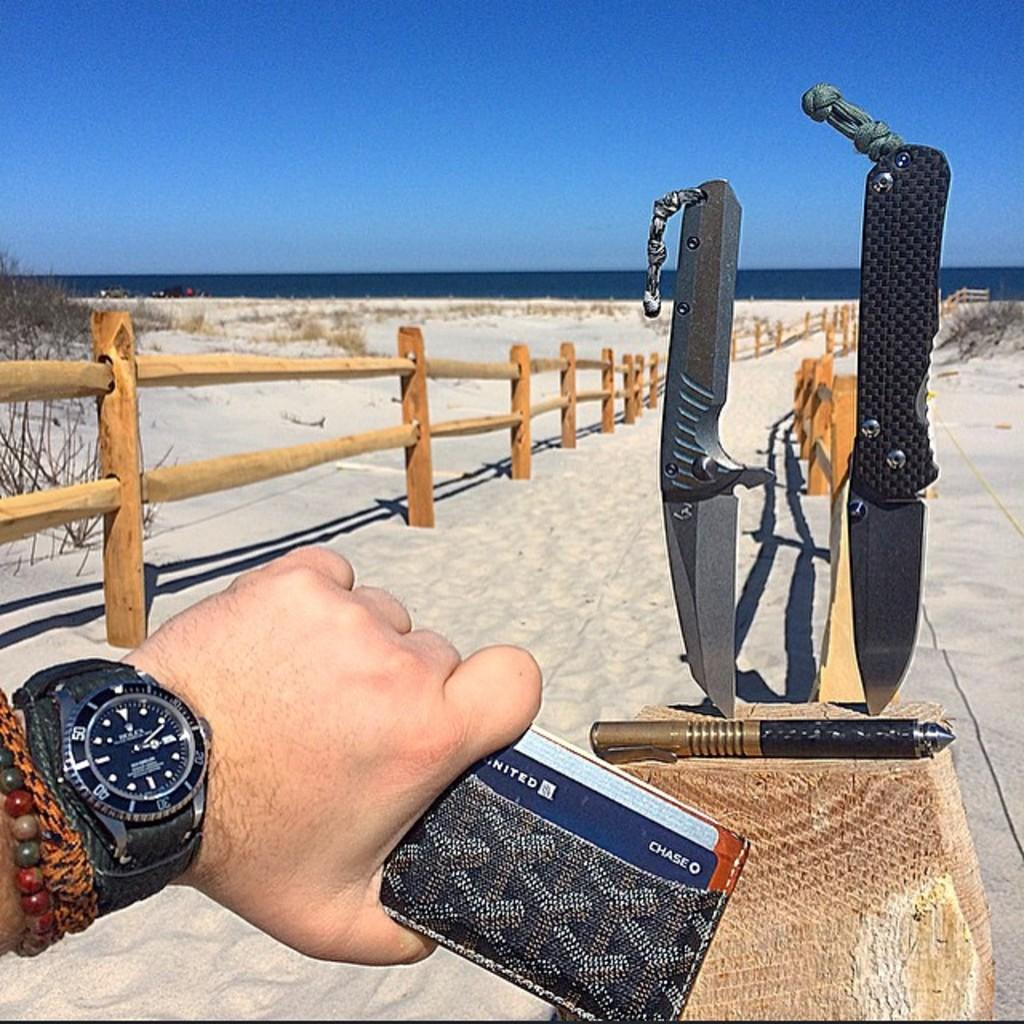<image>
Share a concise interpretation of the image provided. The person has a Chase credit card which helps him collect United Airline miles. 